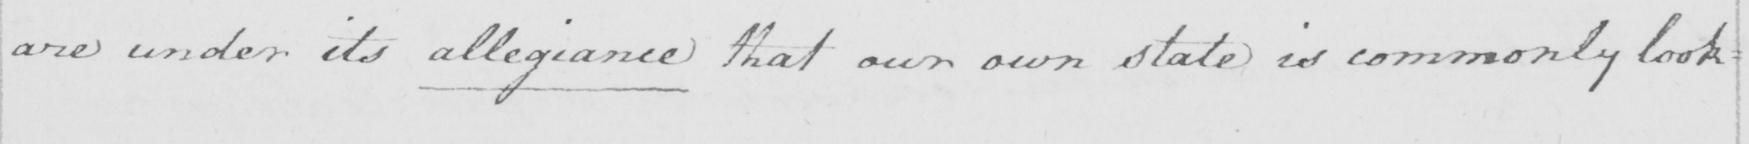What is written in this line of handwriting? are under its allegiance that our own state is commonly look= 